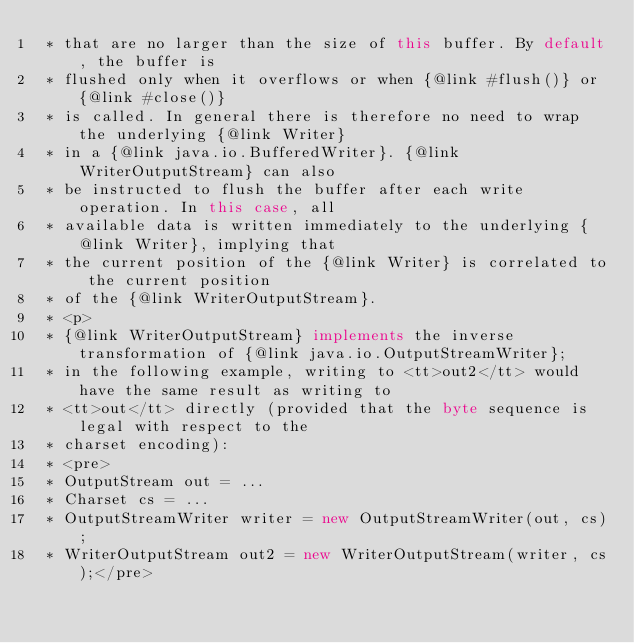<code> <loc_0><loc_0><loc_500><loc_500><_Java_> * that are no larger than the size of this buffer. By default, the buffer is
 * flushed only when it overflows or when {@link #flush()} or {@link #close()}
 * is called. In general there is therefore no need to wrap the underlying {@link Writer}
 * in a {@link java.io.BufferedWriter}. {@link WriterOutputStream} can also
 * be instructed to flush the buffer after each write operation. In this case, all
 * available data is written immediately to the underlying {@link Writer}, implying that
 * the current position of the {@link Writer} is correlated to the current position
 * of the {@link WriterOutputStream}.
 * <p>
 * {@link WriterOutputStream} implements the inverse transformation of {@link java.io.OutputStreamWriter};
 * in the following example, writing to <tt>out2</tt> would have the same result as writing to
 * <tt>out</tt> directly (provided that the byte sequence is legal with respect to the
 * charset encoding):
 * <pre>
 * OutputStream out = ...
 * Charset cs = ...
 * OutputStreamWriter writer = new OutputStreamWriter(out, cs);
 * WriterOutputStream out2 = new WriterOutputStream(writer, cs);</pre></code> 